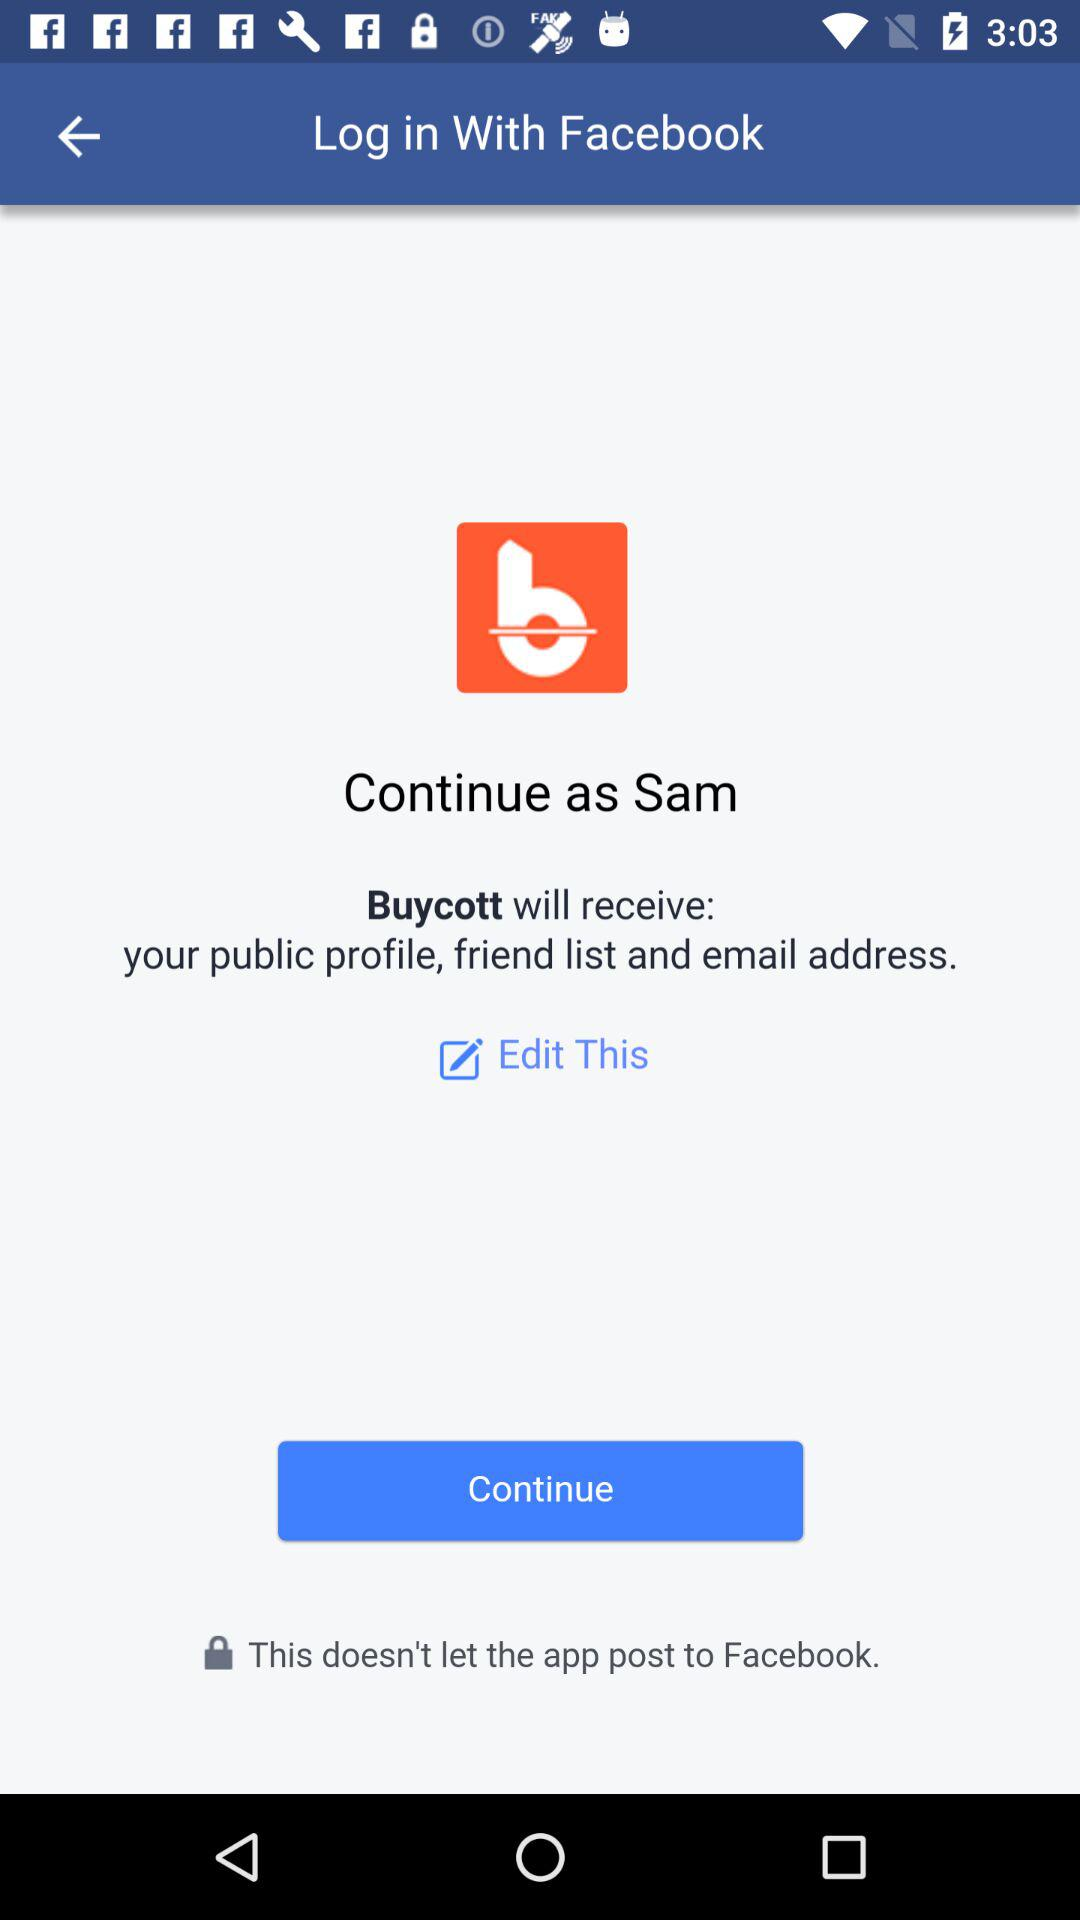What application is asking for permission? The application asking for permission is "Buycott". 